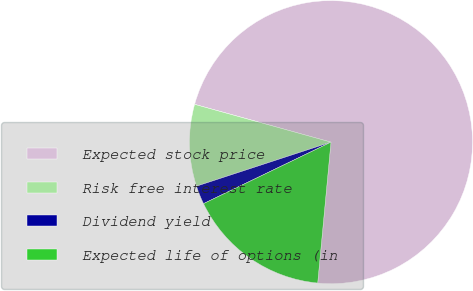Convert chart to OTSL. <chart><loc_0><loc_0><loc_500><loc_500><pie_chart><fcel>Expected stock price<fcel>Risk free interest rate<fcel>Dividend yield<fcel>Expected life of options (in<nl><fcel>72.19%<fcel>9.34%<fcel>2.12%<fcel>16.35%<nl></chart> 